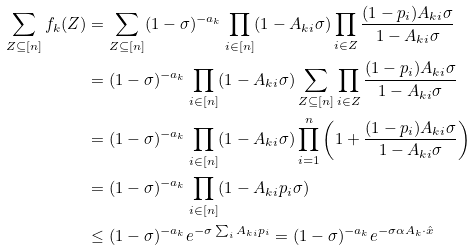Convert formula to latex. <formula><loc_0><loc_0><loc_500><loc_500>\sum _ { Z \subseteq [ n ] } f _ { k } ( Z ) & = \sum _ { Z \subseteq [ n ] } ( 1 - \sigma ) ^ { - a _ { k } } \prod _ { i \in [ n ] } ( 1 - A _ { k i } \sigma ) \prod _ { i \in Z } \frac { ( 1 - p _ { i } ) A _ { k i } \sigma } { 1 - A _ { k i } \sigma } \\ & = ( 1 - \sigma ) ^ { - a _ { k } } \prod _ { i \in [ n ] } ( 1 - A _ { k i } \sigma ) \sum _ { Z \subseteq [ n ] } \prod _ { i \in Z } \frac { ( 1 - p _ { i } ) A _ { k i } \sigma } { 1 - A _ { k i } \sigma } \\ & = ( 1 - \sigma ) ^ { - a _ { k } } \prod _ { i \in [ n ] } ( 1 - A _ { k i } \sigma ) \prod _ { i = 1 } ^ { n } \left ( 1 + \frac { ( 1 - p _ { i } ) A _ { k i } \sigma } { 1 - A _ { k i } \sigma } \right ) \\ & = ( 1 - \sigma ) ^ { - a _ { k } } \prod _ { i \in [ n ] } ( 1 - A _ { k i } p _ { i } \sigma ) \\ & \leq ( 1 - \sigma ) ^ { - a _ { k } } e ^ { - \sigma \sum _ { i } A _ { k i } p _ { i } } = ( 1 - \sigma ) ^ { - a _ { k } } e ^ { - \sigma \alpha A _ { k } \cdot \hat { x } }</formula> 